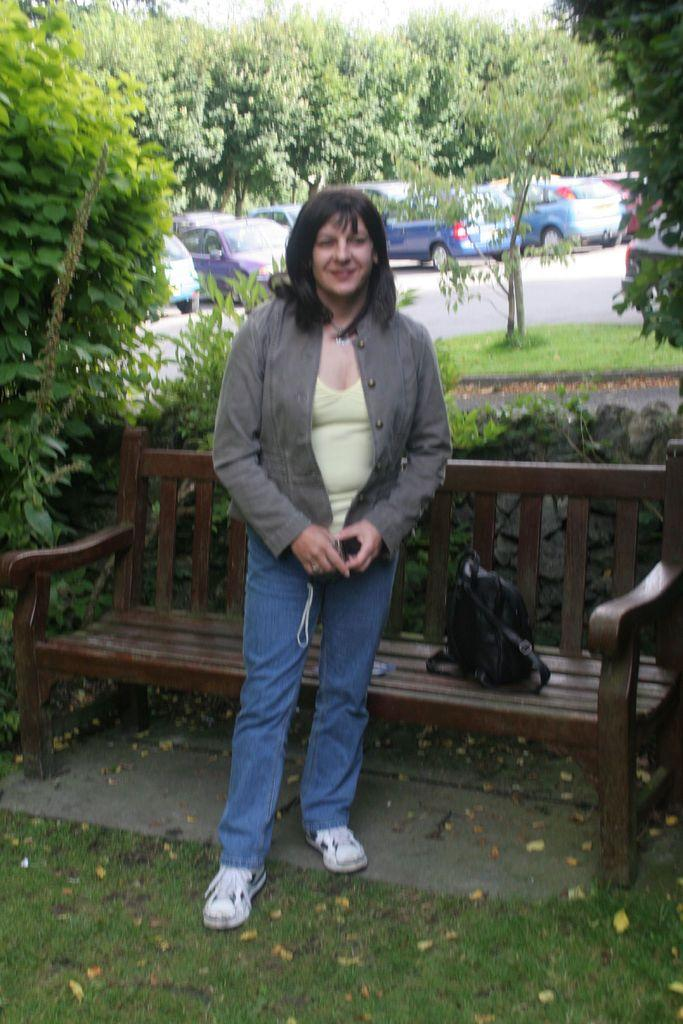Who is the main subject in the image? There is a lady in the image. What is the lady doing in the image? The lady is standing in front of a park bench. What can be seen in the background of the image? There are trees surrounding the area. What type of engine can be seen powering the lady in the image? There is no engine present in the image, and the lady is not being powered by any engine. 